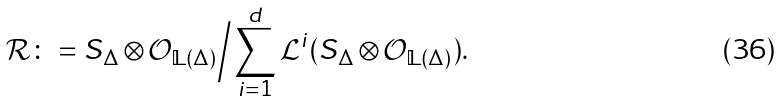<formula> <loc_0><loc_0><loc_500><loc_500>\mathcal { R } \colon = S _ { \Delta } \otimes \mathcal { O } _ { \mathbb { L } ( \Delta ) } \Big { / } \sum _ { i = 1 } ^ { d } \mathcal { L } ^ { i } ( S _ { \Delta } \otimes \mathcal { O } _ { \mathbb { L } ( \Delta ) } ) .</formula> 